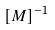Convert formula to latex. <formula><loc_0><loc_0><loc_500><loc_500>[ M ] ^ { - 1 }</formula> 